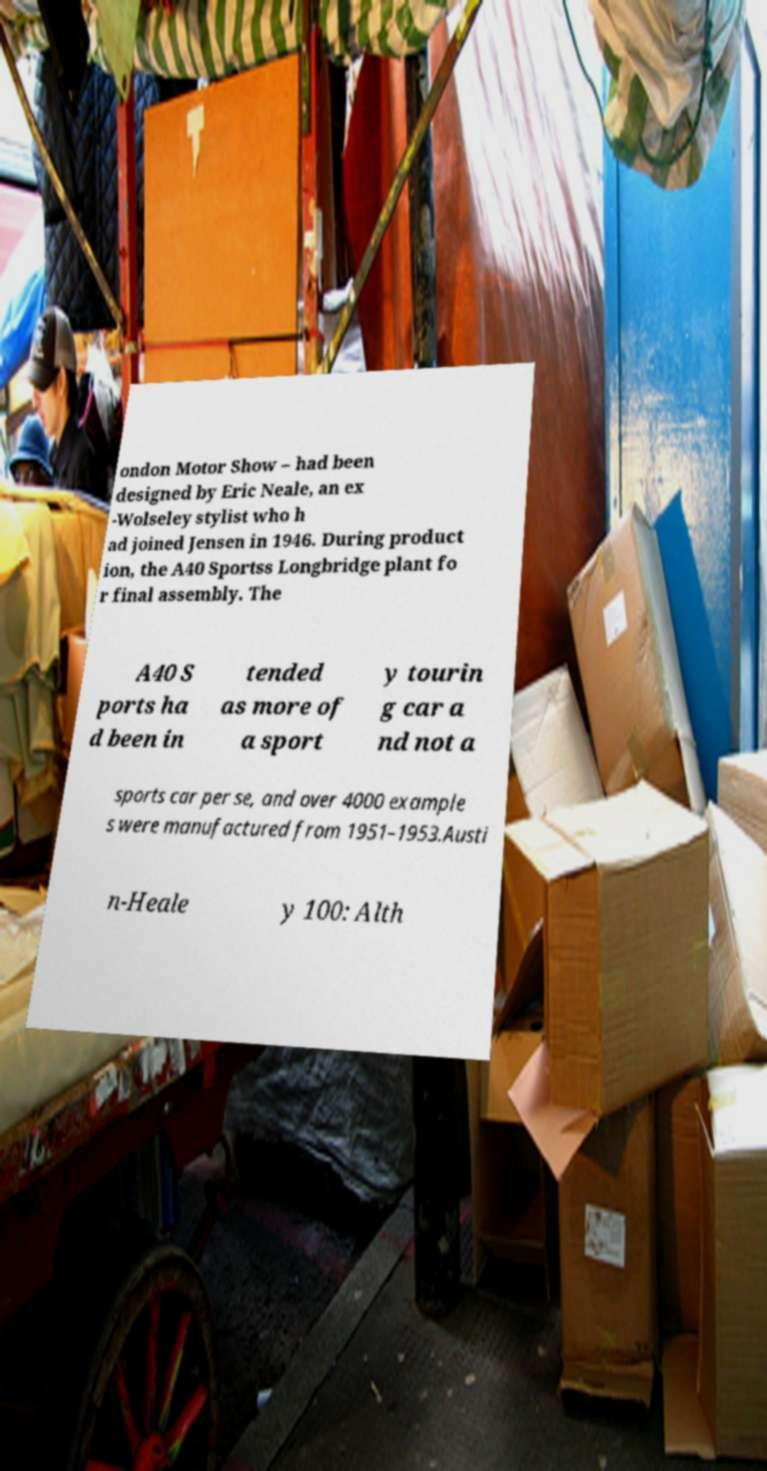There's text embedded in this image that I need extracted. Can you transcribe it verbatim? ondon Motor Show – had been designed by Eric Neale, an ex -Wolseley stylist who h ad joined Jensen in 1946. During product ion, the A40 Sportss Longbridge plant fo r final assembly. The A40 S ports ha d been in tended as more of a sport y tourin g car a nd not a sports car per se, and over 4000 example s were manufactured from 1951–1953.Austi n-Heale y 100: Alth 